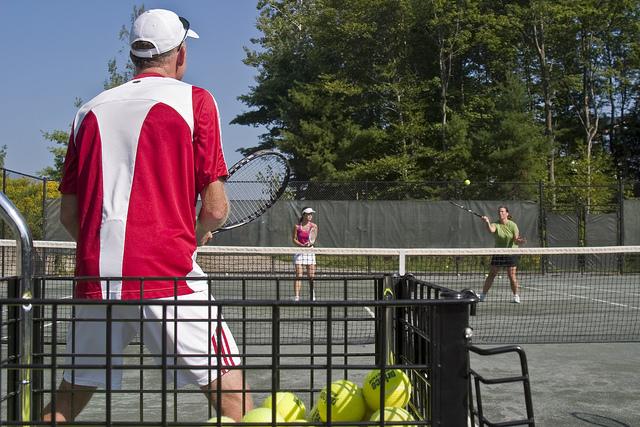How many tennis balls can you see?
Keep it brief. 7. Who is serving?
Give a very brief answer. Woman in green. Where is this?
Short answer required. Tennis court. 